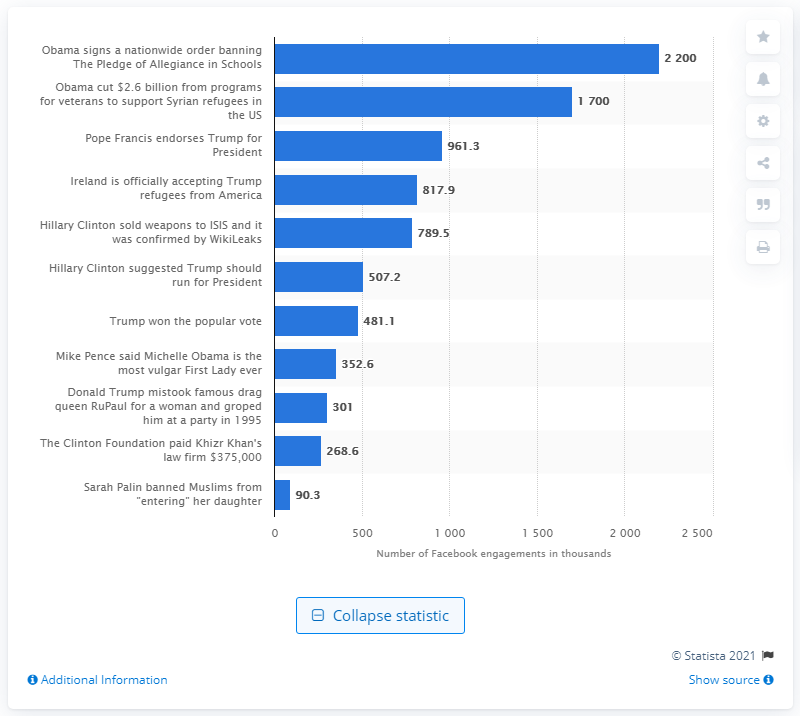What measures have been taken to combat the spread of fake news on platforms like Facebook? Various measures have been implemented to combat fake news on Facebook, including partnering with third-party fact-checkers, using artificial intelligence to detect false stories, prioritizing credible news sources in the feed, warning users before they share flagged content, and providing educational resources to help users spot fake news. 